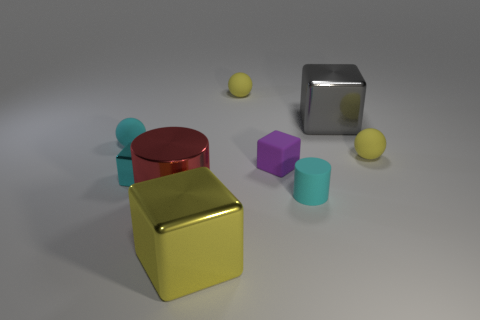The tiny thing that is made of the same material as the red cylinder is what color?
Give a very brief answer. Cyan. Is the shape of the gray shiny thing the same as the tiny purple rubber thing?
Provide a short and direct response. Yes. How many big metallic cubes are both left of the gray object and behind the large yellow object?
Make the answer very short. 0. What number of shiny objects are cylinders or gray blocks?
Make the answer very short. 2. How big is the shiny thing behind the ball on the right side of the tiny cyan cylinder?
Keep it short and to the point. Large. What material is the sphere that is the same color as the small rubber cylinder?
Your answer should be very brief. Rubber. Are there any tiny yellow matte spheres that are right of the large red thing left of the big yellow metallic thing that is to the right of the small cyan block?
Keep it short and to the point. Yes. Do the yellow thing right of the cyan cylinder and the tiny cyan object behind the small purple cube have the same material?
Your response must be concise. Yes. How many things are small rubber objects or cylinders that are on the right side of the big yellow block?
Provide a succinct answer. 5. What number of big gray things are the same shape as the small metallic object?
Give a very brief answer. 1. 